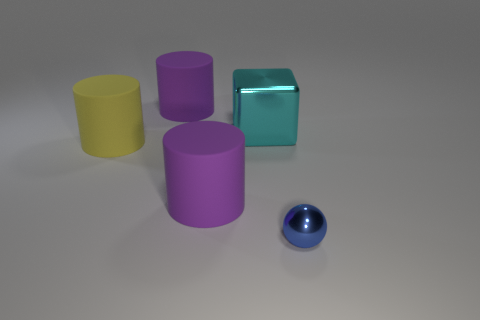Is there a blue shiny thing of the same size as the yellow cylinder?
Your answer should be very brief. No. There is a thing behind the cyan thing; is it the same size as the tiny shiny sphere?
Provide a succinct answer. No. Is the number of metal things that are in front of the yellow cylinder greater than the number of large yellow rubber things?
Offer a very short reply. No. What size is the cyan block that is made of the same material as the blue sphere?
Your response must be concise. Large. Are there an equal number of cyan cubes that are in front of the shiny cube and tiny shiny things that are in front of the yellow matte object?
Give a very brief answer. No. There is a metallic thing in front of the big cyan object; what is its color?
Keep it short and to the point. Blue. Are there the same number of small things that are to the left of the large yellow cylinder and small purple spheres?
Give a very brief answer. Yes. What number of other objects are the same shape as the large cyan shiny object?
Your answer should be compact. 0. There is a tiny blue metallic thing; how many spheres are in front of it?
Provide a short and direct response. 0. There is a thing that is in front of the large yellow cylinder and on the left side of the small ball; what size is it?
Your answer should be compact. Large. 